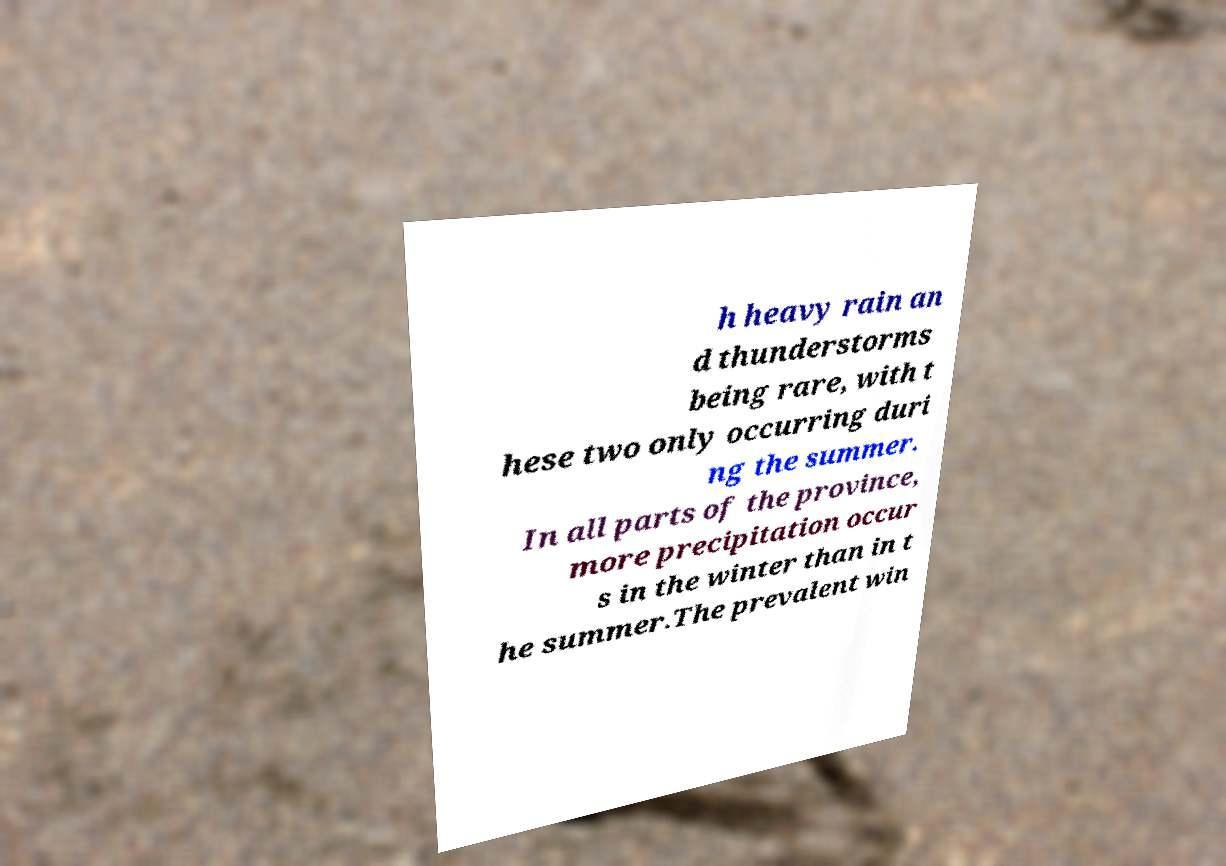Can you accurately transcribe the text from the provided image for me? h heavy rain an d thunderstorms being rare, with t hese two only occurring duri ng the summer. In all parts of the province, more precipitation occur s in the winter than in t he summer.The prevalent win 